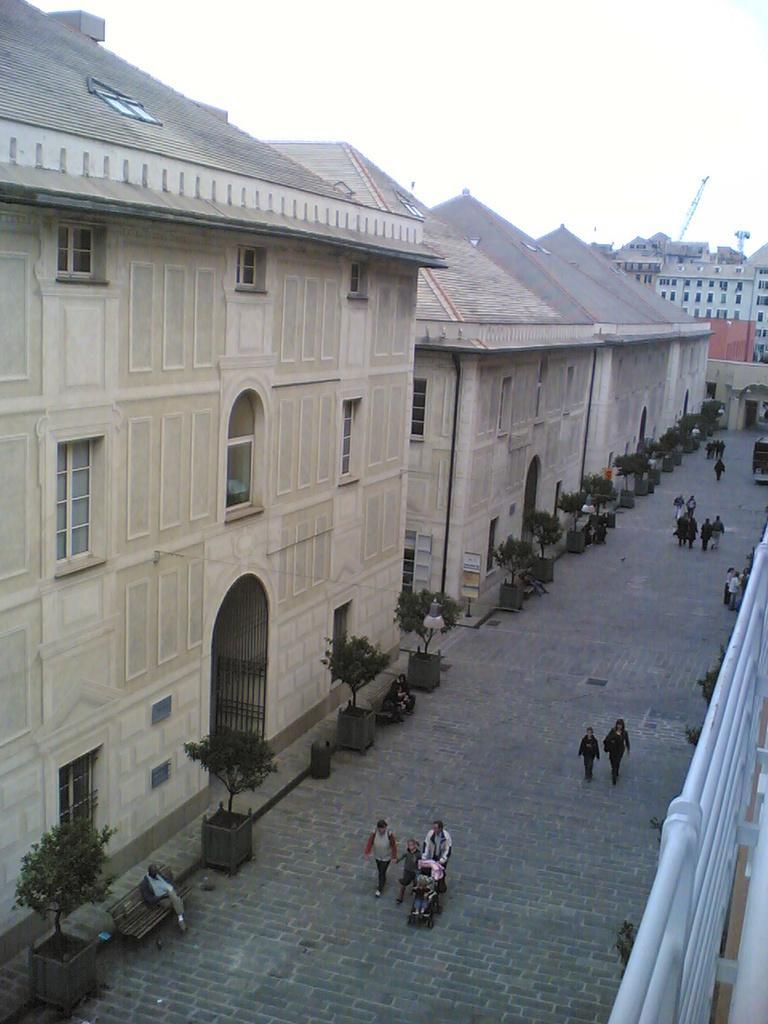In one or two sentences, can you explain what this image depicts? In the picture I can see people walking on the ground. In the background I can see buildings, trees, the sky and some other objects. 